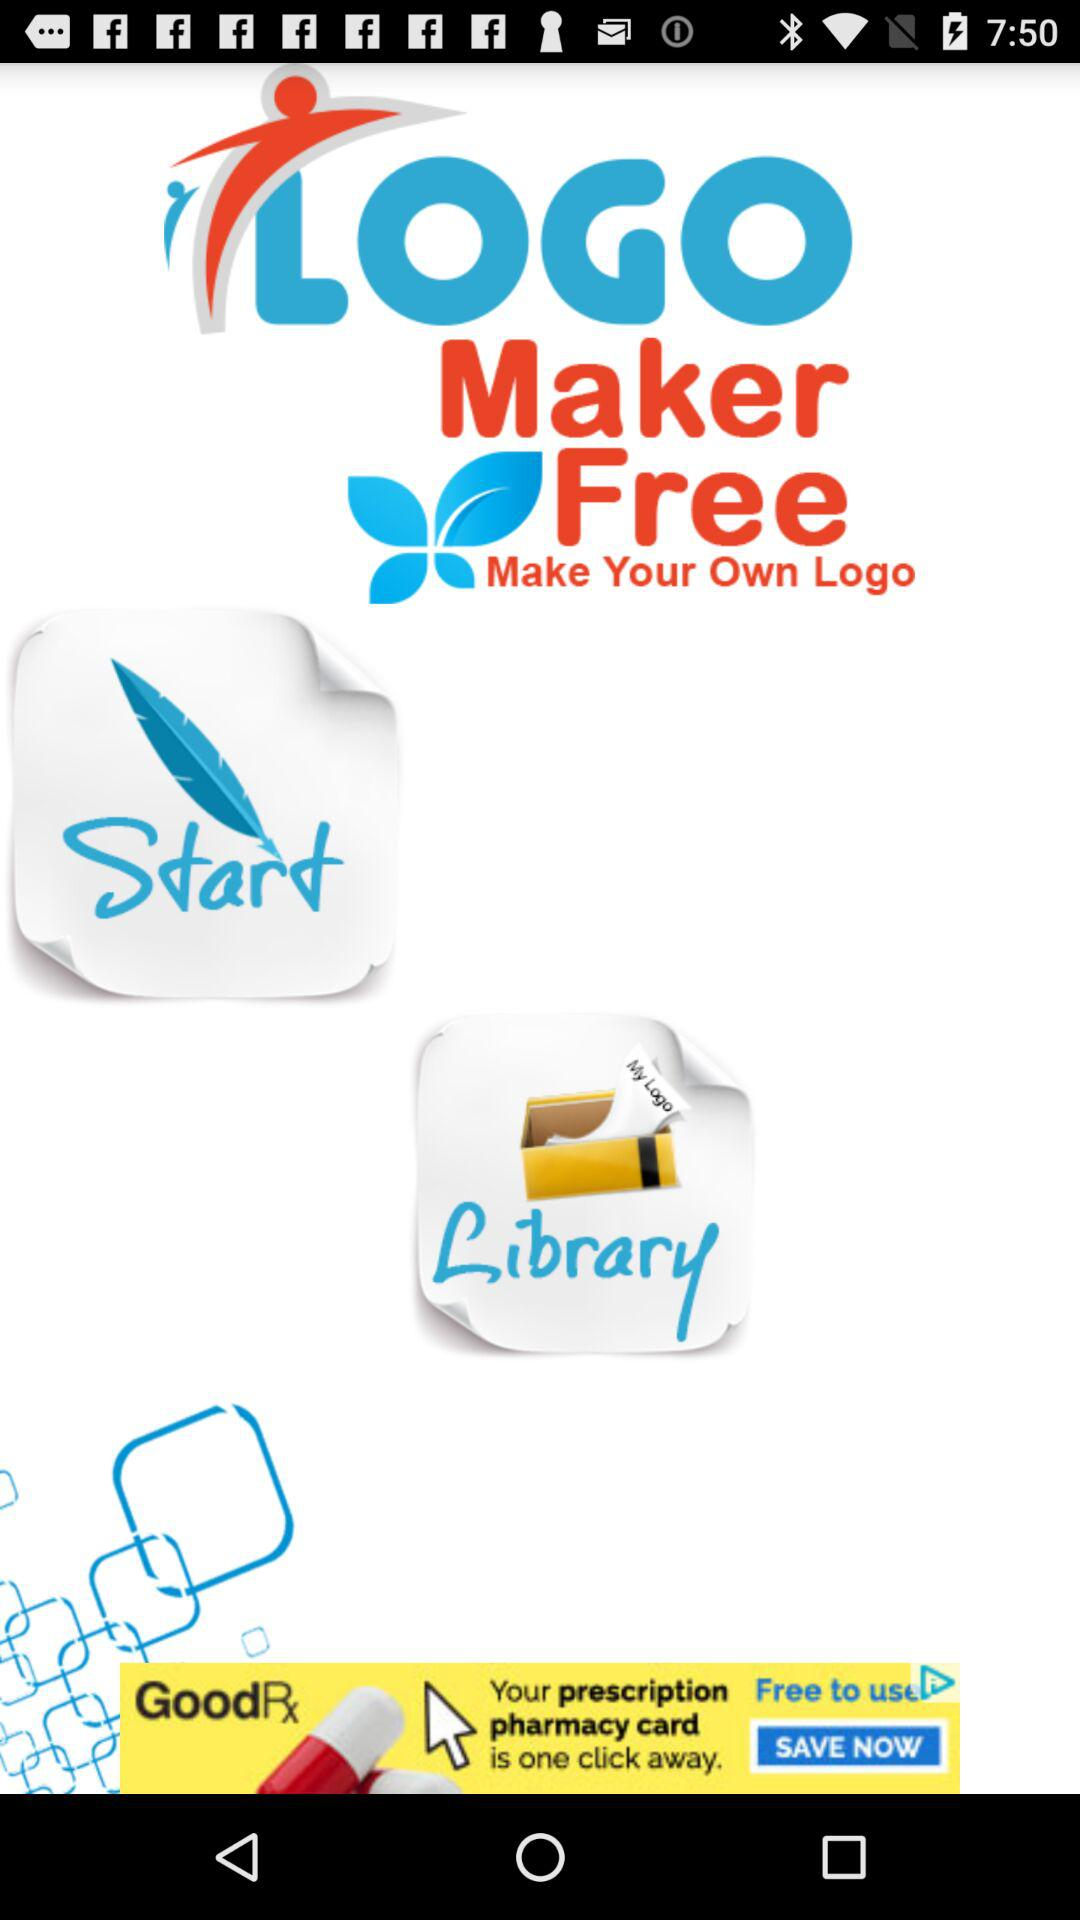What is the name of the application? The name of the application is "LOGO Maker Free". 